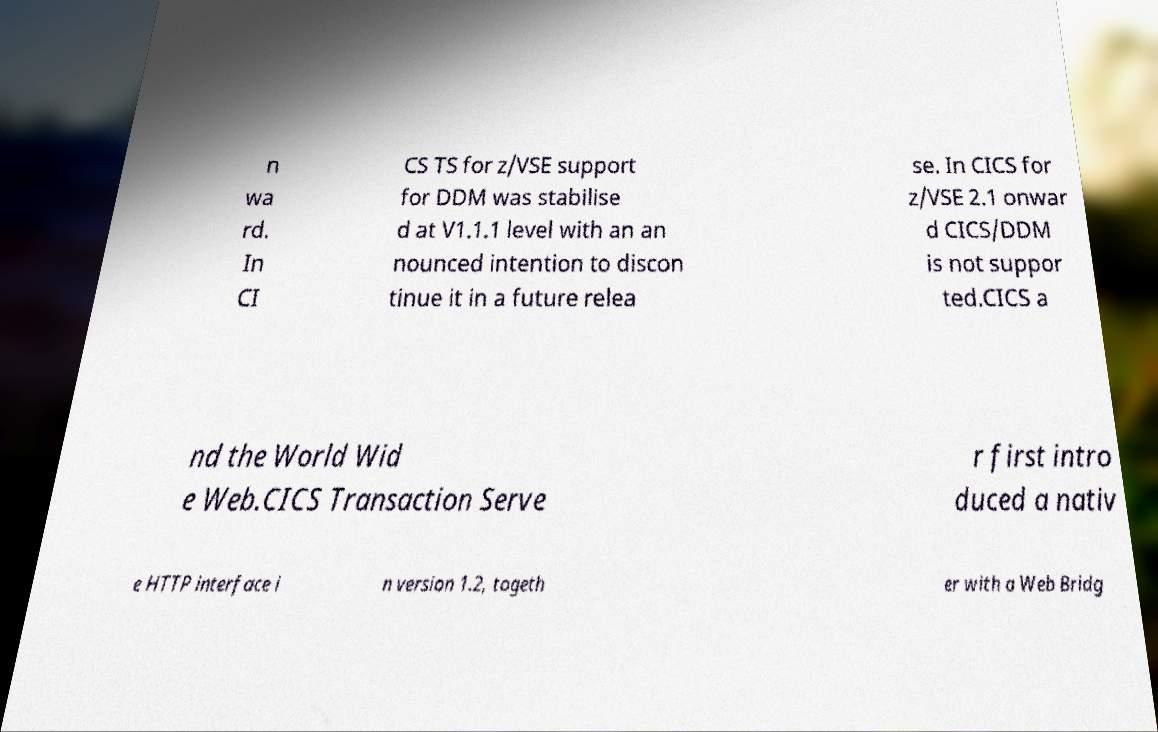Please read and relay the text visible in this image. What does it say? n wa rd. In CI CS TS for z/VSE support for DDM was stabilise d at V1.1.1 level with an an nounced intention to discon tinue it in a future relea se. In CICS for z/VSE 2.1 onwar d CICS/DDM is not suppor ted.CICS a nd the World Wid e Web.CICS Transaction Serve r first intro duced a nativ e HTTP interface i n version 1.2, togeth er with a Web Bridg 